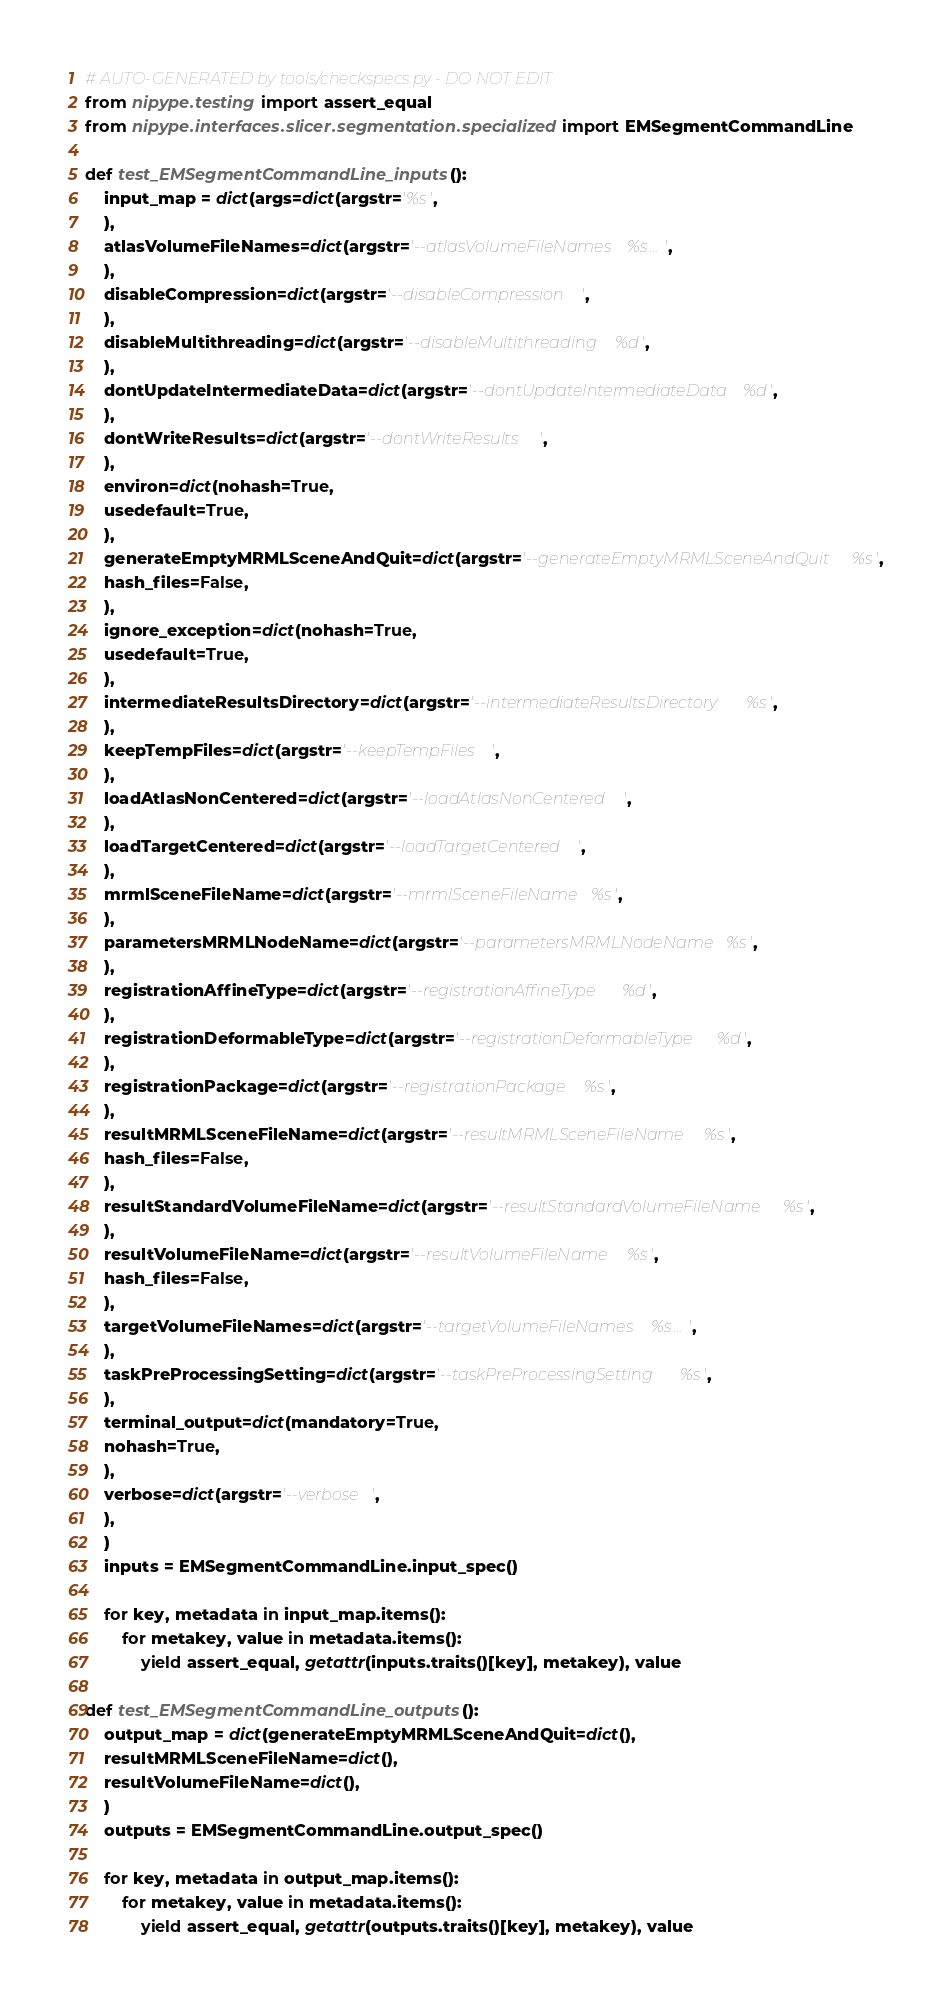<code> <loc_0><loc_0><loc_500><loc_500><_Python_># AUTO-GENERATED by tools/checkspecs.py - DO NOT EDIT
from nipype.testing import assert_equal
from nipype.interfaces.slicer.segmentation.specialized import EMSegmentCommandLine

def test_EMSegmentCommandLine_inputs():
    input_map = dict(args=dict(argstr='%s',
    ),
    atlasVolumeFileNames=dict(argstr='--atlasVolumeFileNames %s...',
    ),
    disableCompression=dict(argstr='--disableCompression ',
    ),
    disableMultithreading=dict(argstr='--disableMultithreading %d',
    ),
    dontUpdateIntermediateData=dict(argstr='--dontUpdateIntermediateData %d',
    ),
    dontWriteResults=dict(argstr='--dontWriteResults ',
    ),
    environ=dict(nohash=True,
    usedefault=True,
    ),
    generateEmptyMRMLSceneAndQuit=dict(argstr='--generateEmptyMRMLSceneAndQuit %s',
    hash_files=False,
    ),
    ignore_exception=dict(nohash=True,
    usedefault=True,
    ),
    intermediateResultsDirectory=dict(argstr='--intermediateResultsDirectory %s',
    ),
    keepTempFiles=dict(argstr='--keepTempFiles ',
    ),
    loadAtlasNonCentered=dict(argstr='--loadAtlasNonCentered ',
    ),
    loadTargetCentered=dict(argstr='--loadTargetCentered ',
    ),
    mrmlSceneFileName=dict(argstr='--mrmlSceneFileName %s',
    ),
    parametersMRMLNodeName=dict(argstr='--parametersMRMLNodeName %s',
    ),
    registrationAffineType=dict(argstr='--registrationAffineType %d',
    ),
    registrationDeformableType=dict(argstr='--registrationDeformableType %d',
    ),
    registrationPackage=dict(argstr='--registrationPackage %s',
    ),
    resultMRMLSceneFileName=dict(argstr='--resultMRMLSceneFileName %s',
    hash_files=False,
    ),
    resultStandardVolumeFileName=dict(argstr='--resultStandardVolumeFileName %s',
    ),
    resultVolumeFileName=dict(argstr='--resultVolumeFileName %s',
    hash_files=False,
    ),
    targetVolumeFileNames=dict(argstr='--targetVolumeFileNames %s...',
    ),
    taskPreProcessingSetting=dict(argstr='--taskPreProcessingSetting %s',
    ),
    terminal_output=dict(mandatory=True,
    nohash=True,
    ),
    verbose=dict(argstr='--verbose ',
    ),
    )
    inputs = EMSegmentCommandLine.input_spec()

    for key, metadata in input_map.items():
        for metakey, value in metadata.items():
            yield assert_equal, getattr(inputs.traits()[key], metakey), value

def test_EMSegmentCommandLine_outputs():
    output_map = dict(generateEmptyMRMLSceneAndQuit=dict(),
    resultMRMLSceneFileName=dict(),
    resultVolumeFileName=dict(),
    )
    outputs = EMSegmentCommandLine.output_spec()

    for key, metadata in output_map.items():
        for metakey, value in metadata.items():
            yield assert_equal, getattr(outputs.traits()[key], metakey), value

</code> 